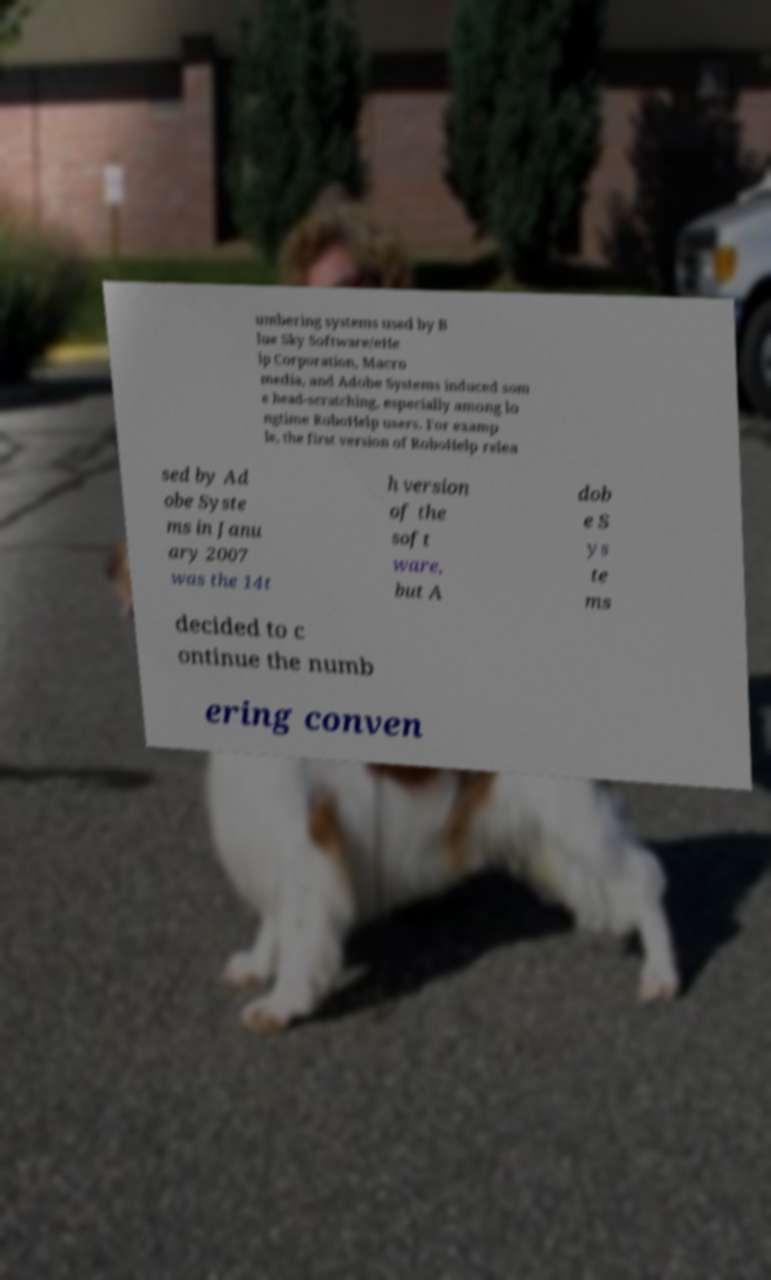There's text embedded in this image that I need extracted. Can you transcribe it verbatim? umbering systems used by B lue Sky Software/eHe lp Corporation, Macro media, and Adobe Systems induced som e head-scratching, especially among lo ngtime RoboHelp users. For examp le, the first version of RoboHelp relea sed by Ad obe Syste ms in Janu ary 2007 was the 14t h version of the soft ware, but A dob e S ys te ms decided to c ontinue the numb ering conven 